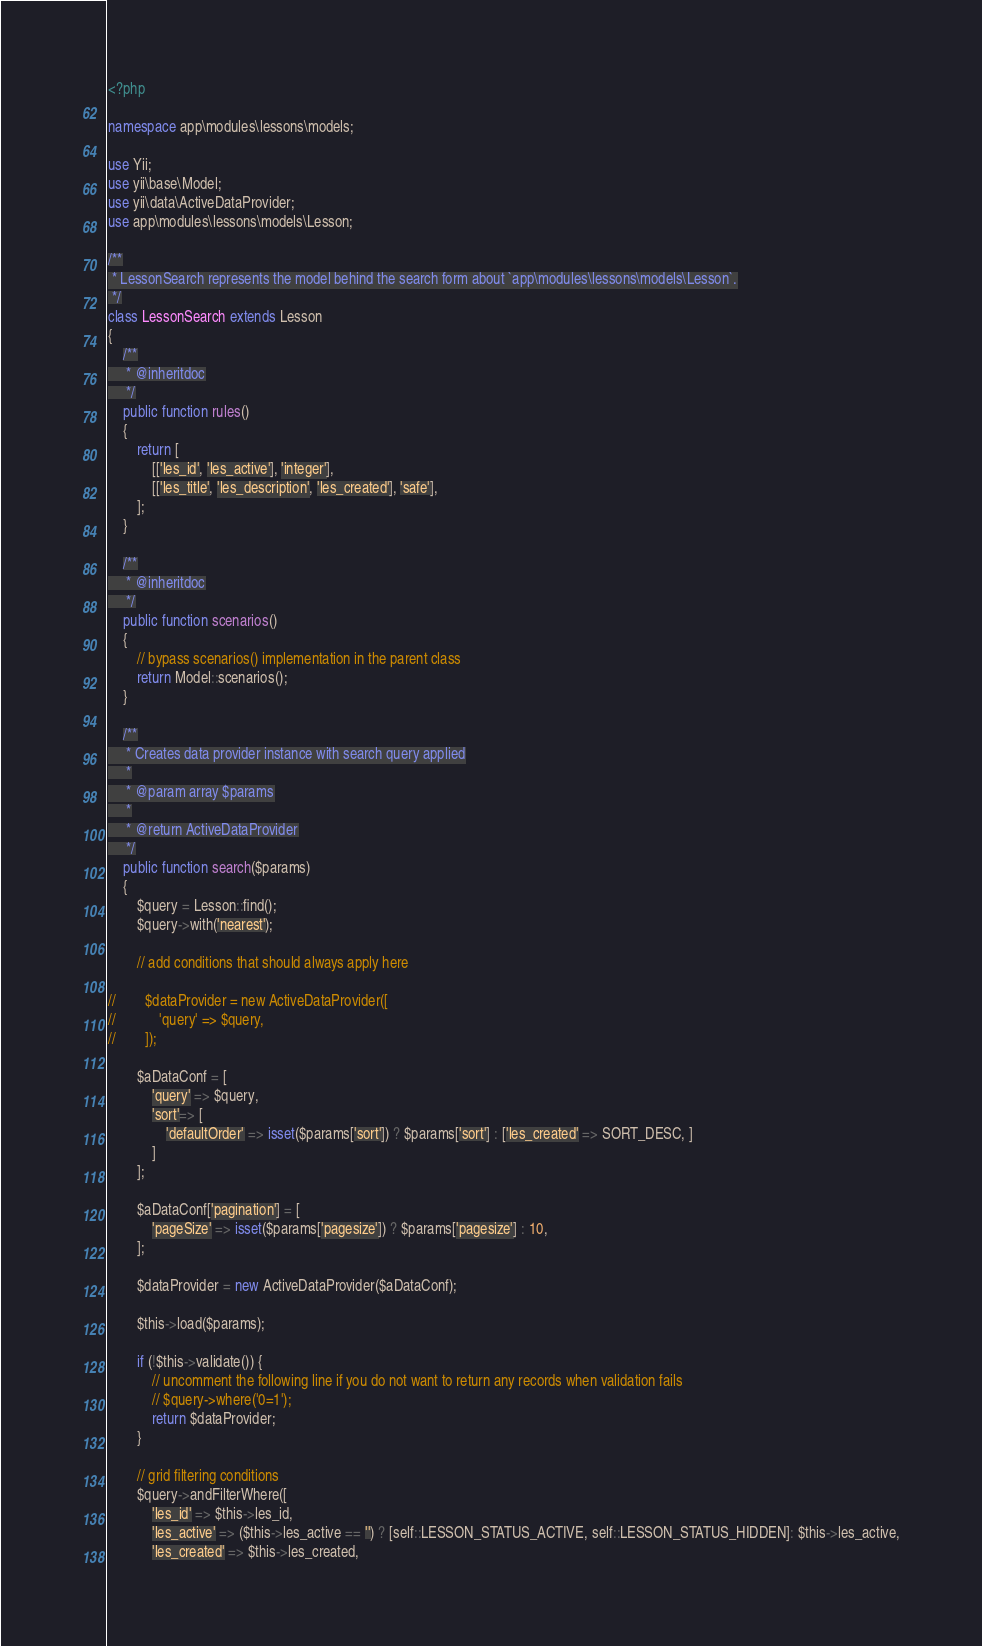Convert code to text. <code><loc_0><loc_0><loc_500><loc_500><_PHP_><?php

namespace app\modules\lessons\models;

use Yii;
use yii\base\Model;
use yii\data\ActiveDataProvider;
use app\modules\lessons\models\Lesson;

/**
 * LessonSearch represents the model behind the search form about `app\modules\lessons\models\Lesson`.
 */
class LessonSearch extends Lesson
{
    /**
     * @inheritdoc
     */
    public function rules()
    {
        return [
            [['les_id', 'les_active'], 'integer'],
            [['les_title', 'les_description', 'les_created'], 'safe'],
        ];
    }

    /**
     * @inheritdoc
     */
    public function scenarios()
    {
        // bypass scenarios() implementation in the parent class
        return Model::scenarios();
    }

    /**
     * Creates data provider instance with search query applied
     *
     * @param array $params
     *
     * @return ActiveDataProvider
     */
    public function search($params)
    {
        $query = Lesson::find();
        $query->with('nearest');

        // add conditions that should always apply here

//        $dataProvider = new ActiveDataProvider([
//            'query' => $query,
//        ]);

        $aDataConf = [
            'query' => $query,
            'sort'=> [
                'defaultOrder' => isset($params['sort']) ? $params['sort'] : ['les_created' => SORT_DESC, ]
            ]
        ];

        $aDataConf['pagination'] = [
            'pageSize' => isset($params['pagesize']) ? $params['pagesize'] : 10,
        ];

        $dataProvider = new ActiveDataProvider($aDataConf);

        $this->load($params);

        if (!$this->validate()) {
            // uncomment the following line if you do not want to return any records when validation fails
            // $query->where('0=1');
            return $dataProvider;
        }

        // grid filtering conditions
        $query->andFilterWhere([
            'les_id' => $this->les_id,
            'les_active' => ($this->les_active == '') ? [self::LESSON_STATUS_ACTIVE, self::LESSON_STATUS_HIDDEN]: $this->les_active,
            'les_created' => $this->les_created,</code> 